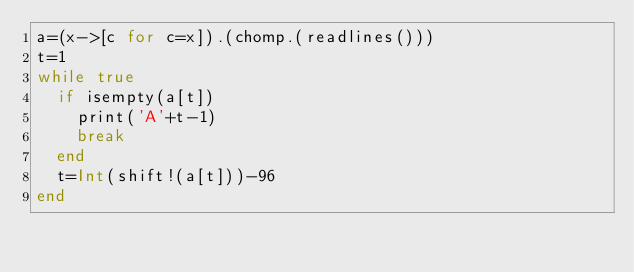Convert code to text. <code><loc_0><loc_0><loc_500><loc_500><_Julia_>a=(x->[c for c=x]).(chomp.(readlines()))
t=1
while true
  if isempty(a[t])
    print('A'+t-1)
    break
  end
  t=Int(shift!(a[t]))-96
end</code> 